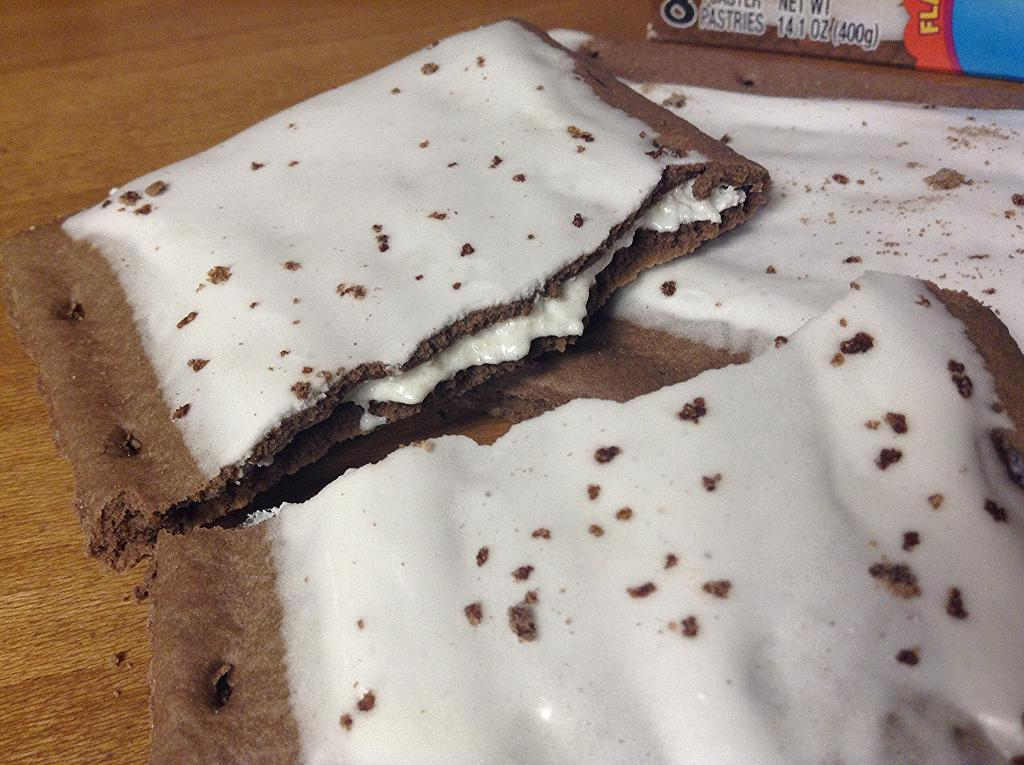What type of food is depicted in the image? There is a broken biscuit with cream in the image. Where is the biscuit located? The biscuit is placed on a table. How many chickens are present in the image? There are no chickens present in the image; it features a broken biscuit with cream on a table. Is there a lock visible on the table in the image? There is no lock visible in the image; it only shows a broken biscuit with cream on a table. 